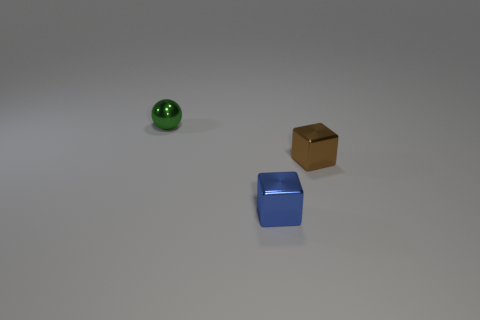Add 1 purple matte cubes. How many objects exist? 4 Subtract all blocks. How many objects are left? 1 Subtract 0 purple balls. How many objects are left? 3 Subtract all purple shiny spheres. Subtract all brown cubes. How many objects are left? 2 Add 1 tiny green shiny spheres. How many tiny green shiny spheres are left? 2 Add 3 blue shiny cubes. How many blue shiny cubes exist? 4 